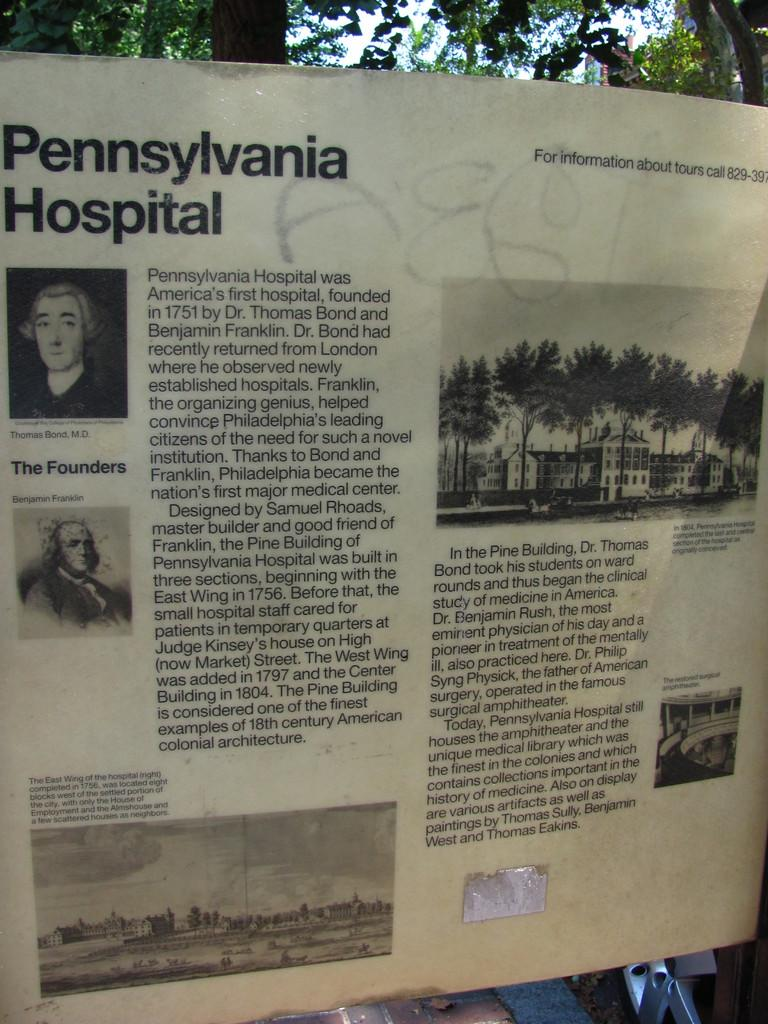What is the main object in the image with text and images? There is a board with text and images in the image. What type of natural elements can be seen at the top of the image? Trees are visible at the top of the image. What type of man-made structure is present at the top of the image? There is a building at the top of the image. What is visible in the background of the image? The sky is visible at the top of the image. Where is the tent located in the image? There is no tent present in the image. What type of ornament is hanging from the building in the image? There is no ornament visible in the image, as the focus is on the board, trees, building, and sky. 